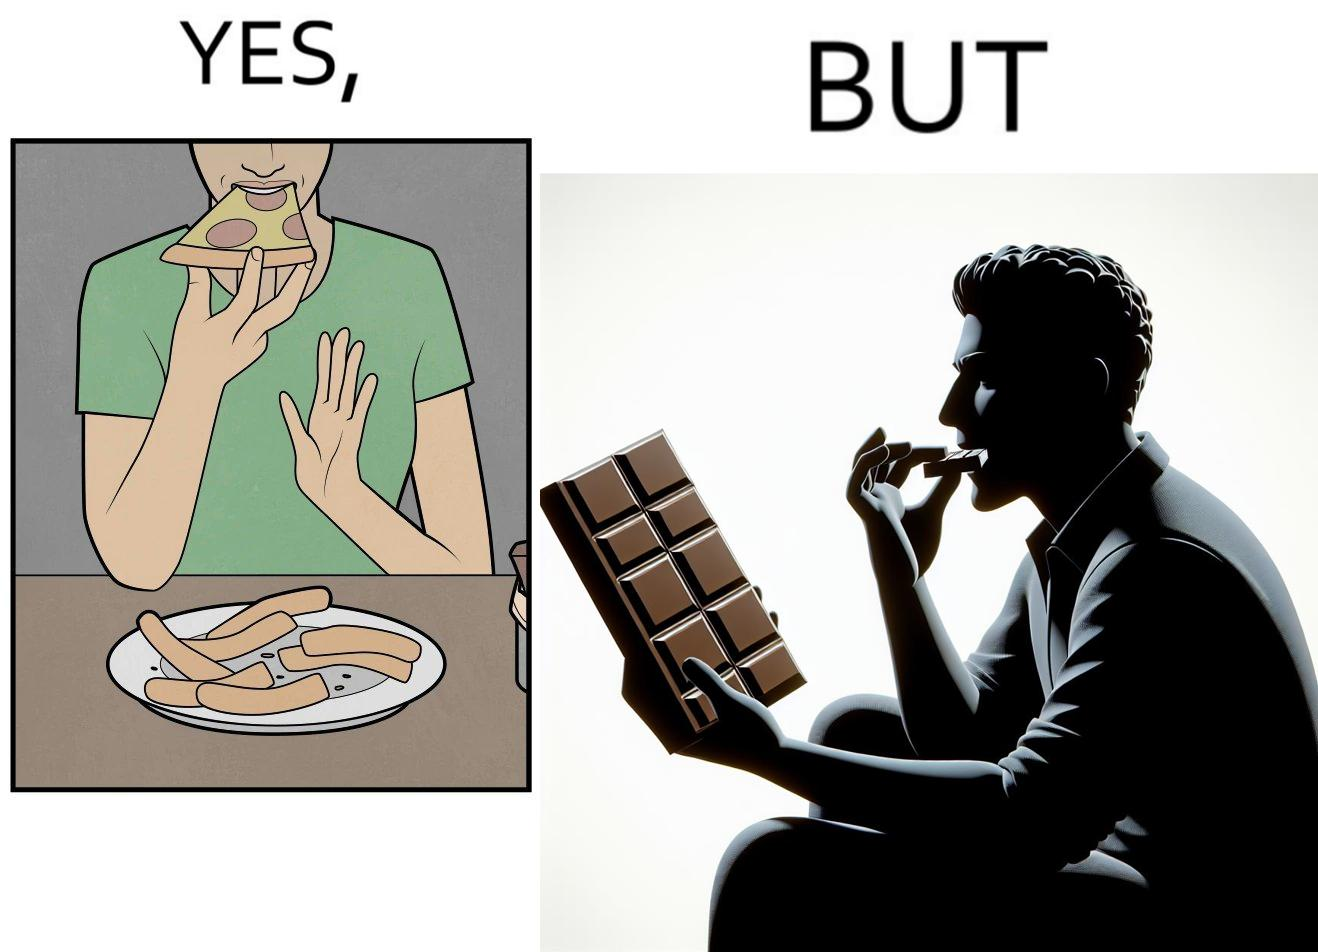What makes this image funny or satirical? the irony in this image is that people waste pizza crust by saying that it is too hard, while they eat hard chocolate without any complaints 